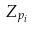Convert formula to latex. <formula><loc_0><loc_0><loc_500><loc_500>Z _ { p _ { i } }</formula> 